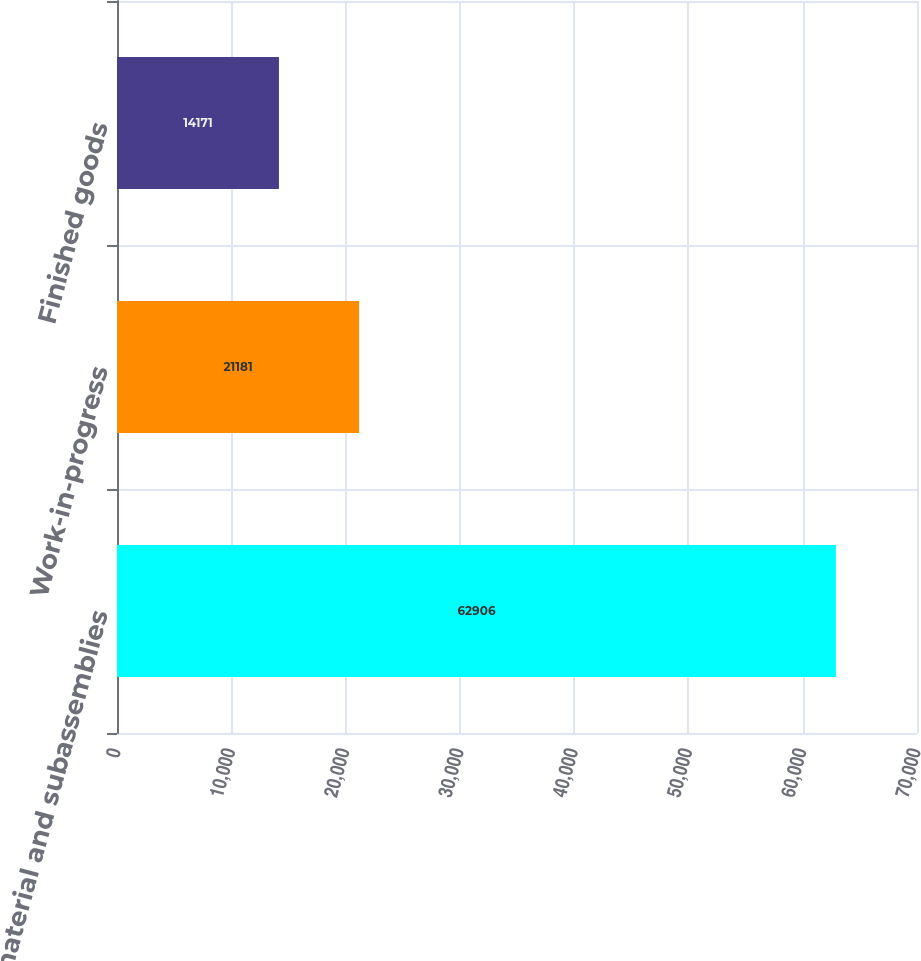<chart> <loc_0><loc_0><loc_500><loc_500><bar_chart><fcel>Raw material and subassemblies<fcel>Work-in-progress<fcel>Finished goods<nl><fcel>62906<fcel>21181<fcel>14171<nl></chart> 